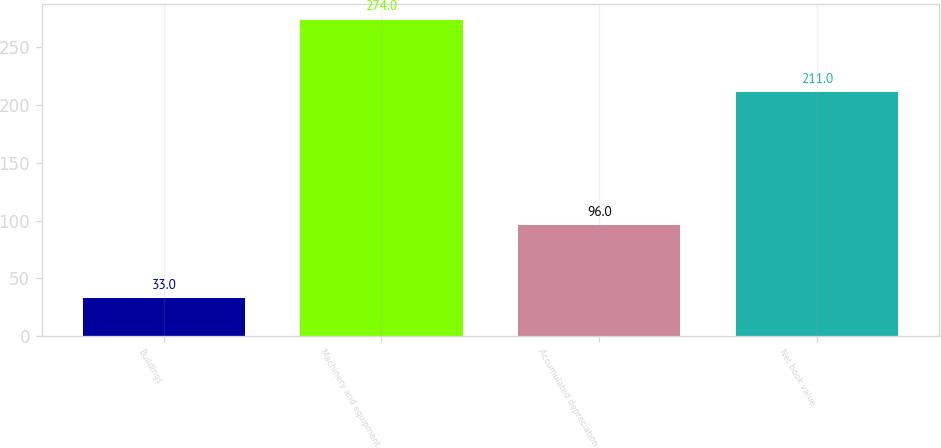Convert chart to OTSL. <chart><loc_0><loc_0><loc_500><loc_500><bar_chart><fcel>Buildings<fcel>Machinery and equipment<fcel>Accumulated depreciation<fcel>Net book value<nl><fcel>33<fcel>274<fcel>96<fcel>211<nl></chart> 